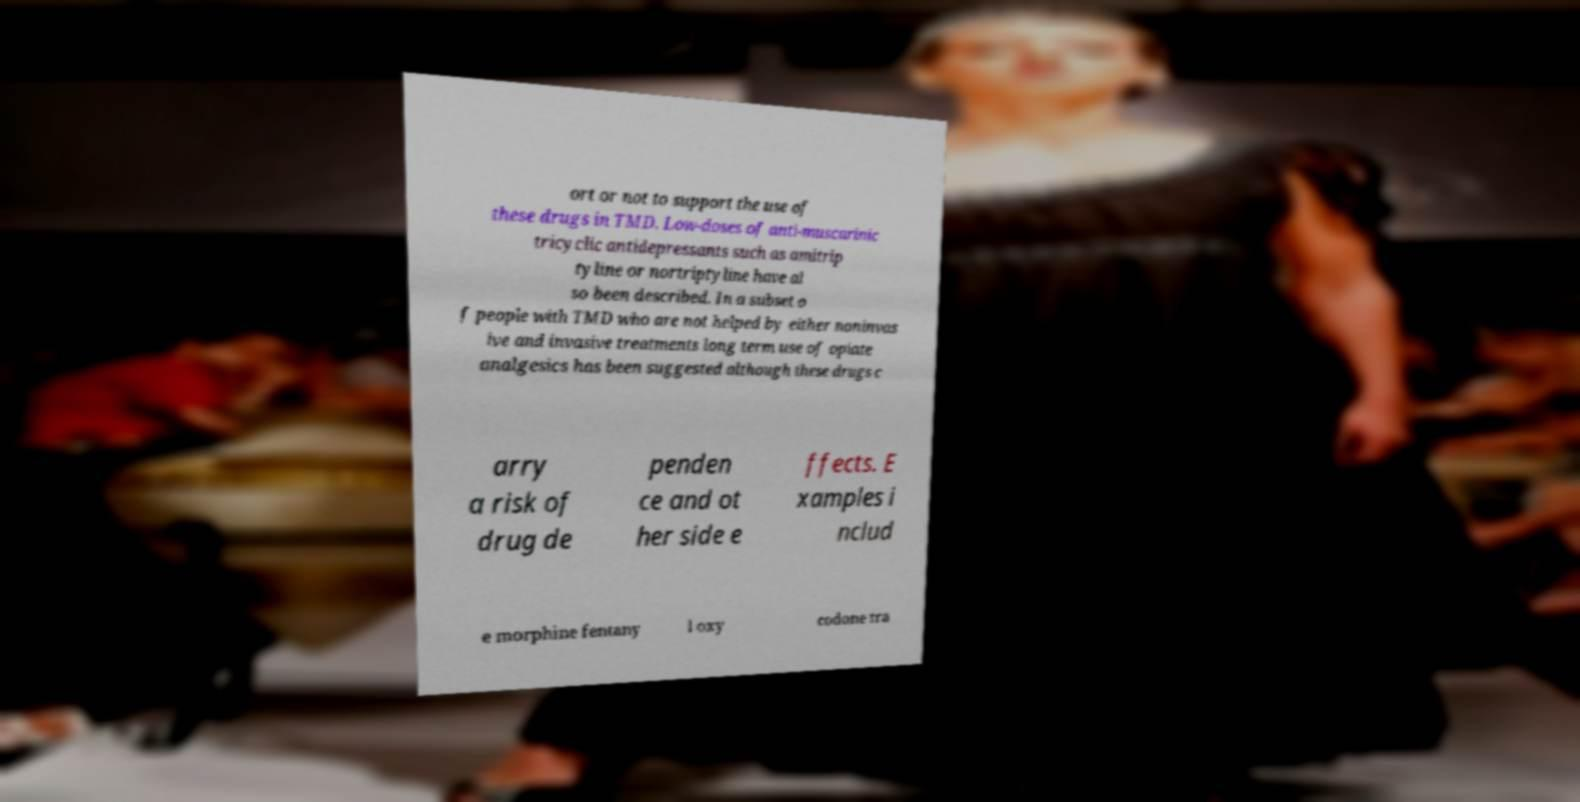There's text embedded in this image that I need extracted. Can you transcribe it verbatim? ort or not to support the use of these drugs in TMD. Low-doses of anti-muscarinic tricyclic antidepressants such as amitrip tyline or nortriptyline have al so been described. In a subset o f people with TMD who are not helped by either noninvas ive and invasive treatments long term use of opiate analgesics has been suggested although these drugs c arry a risk of drug de penden ce and ot her side e ffects. E xamples i nclud e morphine fentany l oxy codone tra 